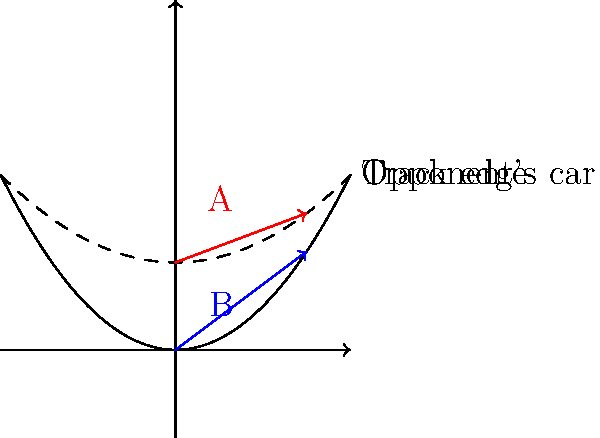When overtaking on a straight, two potential trajectories are shown: trajectory A (red) and trajectory B (blue). Which trajectory is safer for overtaking, and why? To determine the safer overtaking trajectory, we need to consider several factors:

1. Distance from the opponent's car:
   - Trajectory A (red) is closer to the opponent's car.
   - Trajectory B (blue) maintains a greater distance from the opponent.

2. Available space on the track:
   - Trajectory A leaves less room for error, as it's closer to both the opponent and the track edge.
   - Trajectory B provides more space on both sides, allowing for adjustments if needed.

3. Predictability:
   - Trajectory A might be less predictable for the opponent, potentially leading to defensive moves.
   - Trajectory B is more predictable and less likely to cause sudden reactions from the opponent.

4. Aerodynamics:
   - Trajectory A puts the overtaking car in the slipstream of the opponent, which can be beneficial for speed but may affect downforce and stability.
   - Trajectory B allows for cleaner air, maintaining optimal downforce and stability.

5. Exit speed:
   - Trajectory B, being further from the opponent, allows for a smoother acceleration and potentially higher exit speed after the overtake.

Considering these factors, trajectory B (blue) is safer because it:
- Maintains a greater distance from the opponent's car
- Provides more space for adjustments
- Is more predictable for both drivers
- Ensures better aerodynamic stability
- Allows for potentially higher exit speed

While trajectory A might offer a speed advantage due to slipstreaming, the increased risk outweighs this benefit in terms of safety.
Answer: Trajectory B (blue) is safer, as it maintains greater distance from the opponent and track edge, allowing for better control and adjustments during overtaking. 